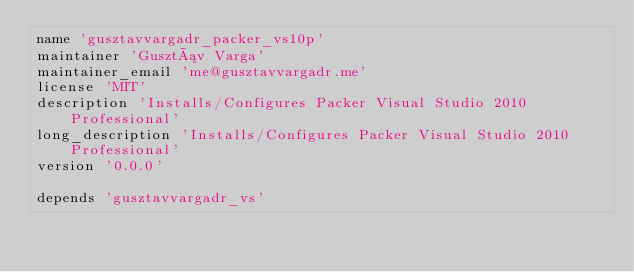<code> <loc_0><loc_0><loc_500><loc_500><_Ruby_>name 'gusztavvargadr_packer_vs10p'
maintainer 'Gusztáv Varga'
maintainer_email 'me@gusztavvargadr.me'
license 'MIT'
description 'Installs/Configures Packer Visual Studio 2010 Professional'
long_description 'Installs/Configures Packer Visual Studio 2010 Professional'
version '0.0.0'

depends 'gusztavvargadr_vs'
</code> 